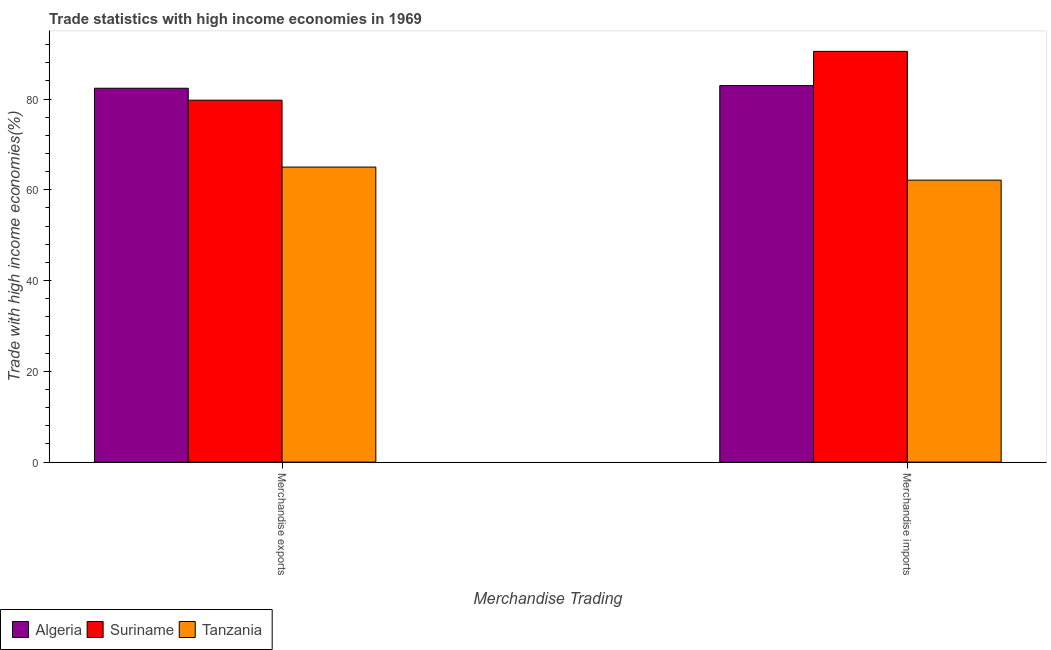How many different coloured bars are there?
Your response must be concise. 3. Are the number of bars per tick equal to the number of legend labels?
Your answer should be compact. Yes. Are the number of bars on each tick of the X-axis equal?
Your answer should be very brief. Yes. How many bars are there on the 2nd tick from the right?
Your response must be concise. 3. What is the merchandise exports in Suriname?
Make the answer very short. 79.74. Across all countries, what is the maximum merchandise exports?
Keep it short and to the point. 82.37. Across all countries, what is the minimum merchandise exports?
Your answer should be very brief. 65.01. In which country was the merchandise exports maximum?
Your answer should be compact. Algeria. In which country was the merchandise imports minimum?
Offer a terse response. Tanzania. What is the total merchandise exports in the graph?
Provide a succinct answer. 227.11. What is the difference between the merchandise exports in Algeria and that in Suriname?
Give a very brief answer. 2.63. What is the difference between the merchandise imports in Tanzania and the merchandise exports in Algeria?
Make the answer very short. -20.25. What is the average merchandise imports per country?
Your answer should be very brief. 78.52. What is the difference between the merchandise exports and merchandise imports in Algeria?
Ensure brevity in your answer.  -0.58. In how many countries, is the merchandise imports greater than 4 %?
Offer a terse response. 3. What is the ratio of the merchandise imports in Algeria to that in Tanzania?
Provide a short and direct response. 1.34. Is the merchandise exports in Suriname less than that in Tanzania?
Provide a succinct answer. No. What does the 2nd bar from the left in Merchandise imports represents?
Keep it short and to the point. Suriname. What does the 3rd bar from the right in Merchandise exports represents?
Give a very brief answer. Algeria. How many bars are there?
Your answer should be very brief. 6. Are all the bars in the graph horizontal?
Offer a terse response. No. What is the difference between two consecutive major ticks on the Y-axis?
Ensure brevity in your answer.  20. What is the title of the graph?
Your answer should be very brief. Trade statistics with high income economies in 1969. Does "Chad" appear as one of the legend labels in the graph?
Offer a terse response. No. What is the label or title of the X-axis?
Your response must be concise. Merchandise Trading. What is the label or title of the Y-axis?
Make the answer very short. Trade with high income economies(%). What is the Trade with high income economies(%) of Algeria in Merchandise exports?
Your response must be concise. 82.37. What is the Trade with high income economies(%) in Suriname in Merchandise exports?
Provide a succinct answer. 79.74. What is the Trade with high income economies(%) of Tanzania in Merchandise exports?
Offer a very short reply. 65.01. What is the Trade with high income economies(%) of Algeria in Merchandise imports?
Give a very brief answer. 82.95. What is the Trade with high income economies(%) in Suriname in Merchandise imports?
Offer a very short reply. 90.5. What is the Trade with high income economies(%) in Tanzania in Merchandise imports?
Offer a very short reply. 62.12. Across all Merchandise Trading, what is the maximum Trade with high income economies(%) of Algeria?
Offer a terse response. 82.95. Across all Merchandise Trading, what is the maximum Trade with high income economies(%) in Suriname?
Your response must be concise. 90.5. Across all Merchandise Trading, what is the maximum Trade with high income economies(%) in Tanzania?
Give a very brief answer. 65.01. Across all Merchandise Trading, what is the minimum Trade with high income economies(%) in Algeria?
Ensure brevity in your answer.  82.37. Across all Merchandise Trading, what is the minimum Trade with high income economies(%) of Suriname?
Keep it short and to the point. 79.74. Across all Merchandise Trading, what is the minimum Trade with high income economies(%) in Tanzania?
Provide a succinct answer. 62.12. What is the total Trade with high income economies(%) of Algeria in the graph?
Offer a terse response. 165.32. What is the total Trade with high income economies(%) of Suriname in the graph?
Offer a very short reply. 170.24. What is the total Trade with high income economies(%) of Tanzania in the graph?
Your response must be concise. 127.13. What is the difference between the Trade with high income economies(%) of Algeria in Merchandise exports and that in Merchandise imports?
Your answer should be compact. -0.58. What is the difference between the Trade with high income economies(%) of Suriname in Merchandise exports and that in Merchandise imports?
Offer a terse response. -10.76. What is the difference between the Trade with high income economies(%) of Tanzania in Merchandise exports and that in Merchandise imports?
Offer a terse response. 2.88. What is the difference between the Trade with high income economies(%) of Algeria in Merchandise exports and the Trade with high income economies(%) of Suriname in Merchandise imports?
Ensure brevity in your answer.  -8.13. What is the difference between the Trade with high income economies(%) of Algeria in Merchandise exports and the Trade with high income economies(%) of Tanzania in Merchandise imports?
Your answer should be compact. 20.25. What is the difference between the Trade with high income economies(%) in Suriname in Merchandise exports and the Trade with high income economies(%) in Tanzania in Merchandise imports?
Your answer should be compact. 17.62. What is the average Trade with high income economies(%) in Algeria per Merchandise Trading?
Provide a succinct answer. 82.66. What is the average Trade with high income economies(%) of Suriname per Merchandise Trading?
Offer a terse response. 85.12. What is the average Trade with high income economies(%) in Tanzania per Merchandise Trading?
Offer a terse response. 63.56. What is the difference between the Trade with high income economies(%) in Algeria and Trade with high income economies(%) in Suriname in Merchandise exports?
Keep it short and to the point. 2.63. What is the difference between the Trade with high income economies(%) of Algeria and Trade with high income economies(%) of Tanzania in Merchandise exports?
Keep it short and to the point. 17.37. What is the difference between the Trade with high income economies(%) in Suriname and Trade with high income economies(%) in Tanzania in Merchandise exports?
Offer a very short reply. 14.73. What is the difference between the Trade with high income economies(%) in Algeria and Trade with high income economies(%) in Suriname in Merchandise imports?
Offer a very short reply. -7.54. What is the difference between the Trade with high income economies(%) in Algeria and Trade with high income economies(%) in Tanzania in Merchandise imports?
Offer a very short reply. 20.83. What is the difference between the Trade with high income economies(%) in Suriname and Trade with high income economies(%) in Tanzania in Merchandise imports?
Provide a succinct answer. 28.37. What is the ratio of the Trade with high income economies(%) in Algeria in Merchandise exports to that in Merchandise imports?
Offer a very short reply. 0.99. What is the ratio of the Trade with high income economies(%) of Suriname in Merchandise exports to that in Merchandise imports?
Your response must be concise. 0.88. What is the ratio of the Trade with high income economies(%) of Tanzania in Merchandise exports to that in Merchandise imports?
Your answer should be compact. 1.05. What is the difference between the highest and the second highest Trade with high income economies(%) in Algeria?
Your response must be concise. 0.58. What is the difference between the highest and the second highest Trade with high income economies(%) of Suriname?
Your answer should be compact. 10.76. What is the difference between the highest and the second highest Trade with high income economies(%) in Tanzania?
Give a very brief answer. 2.88. What is the difference between the highest and the lowest Trade with high income economies(%) in Algeria?
Provide a short and direct response. 0.58. What is the difference between the highest and the lowest Trade with high income economies(%) in Suriname?
Keep it short and to the point. 10.76. What is the difference between the highest and the lowest Trade with high income economies(%) of Tanzania?
Ensure brevity in your answer.  2.88. 